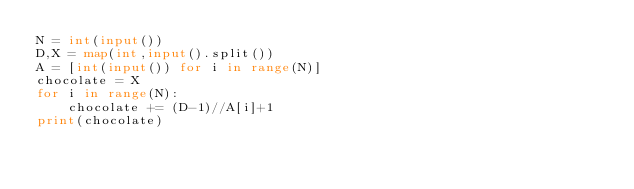<code> <loc_0><loc_0><loc_500><loc_500><_Python_>N = int(input())
D,X = map(int,input().split())
A = [int(input()) for i in range(N)]
chocolate = X
for i in range(N):
    chocolate += (D-1)//A[i]+1
print(chocolate)</code> 